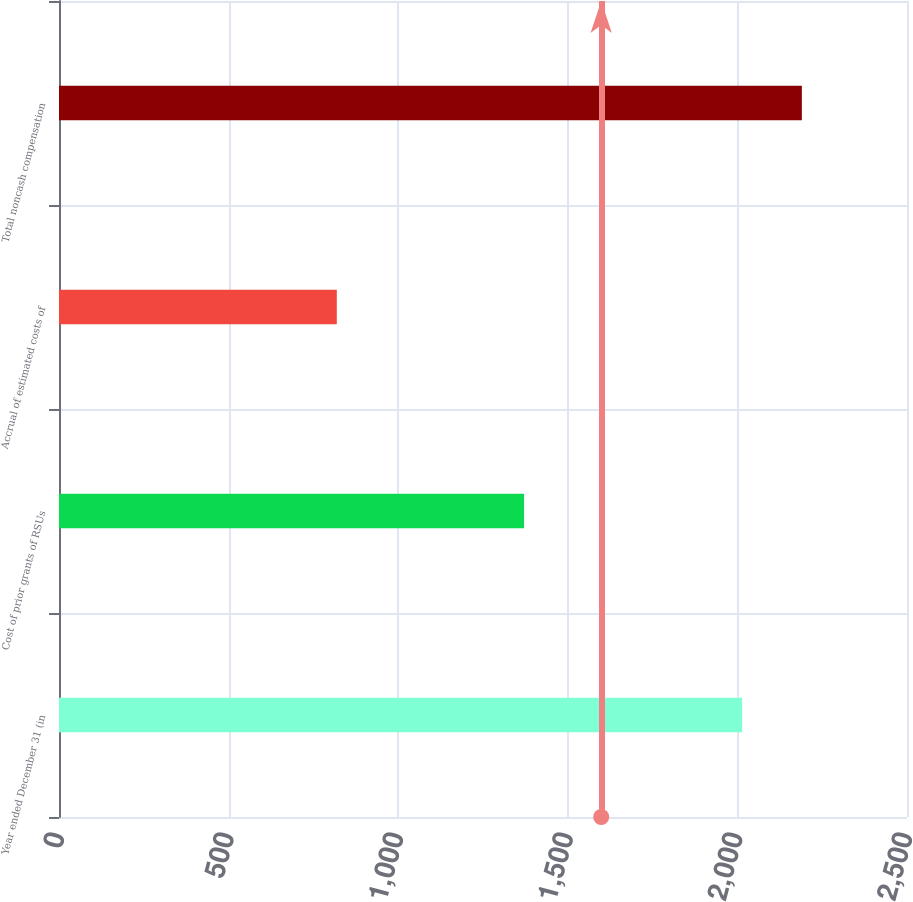Convert chart. <chart><loc_0><loc_0><loc_500><loc_500><bar_chart><fcel>Year ended December 31 (in<fcel>Cost of prior grants of RSUs<fcel>Accrual of estimated costs of<fcel>Total noncash compensation<nl><fcel>2014<fcel>1371<fcel>819<fcel>2190<nl></chart> 